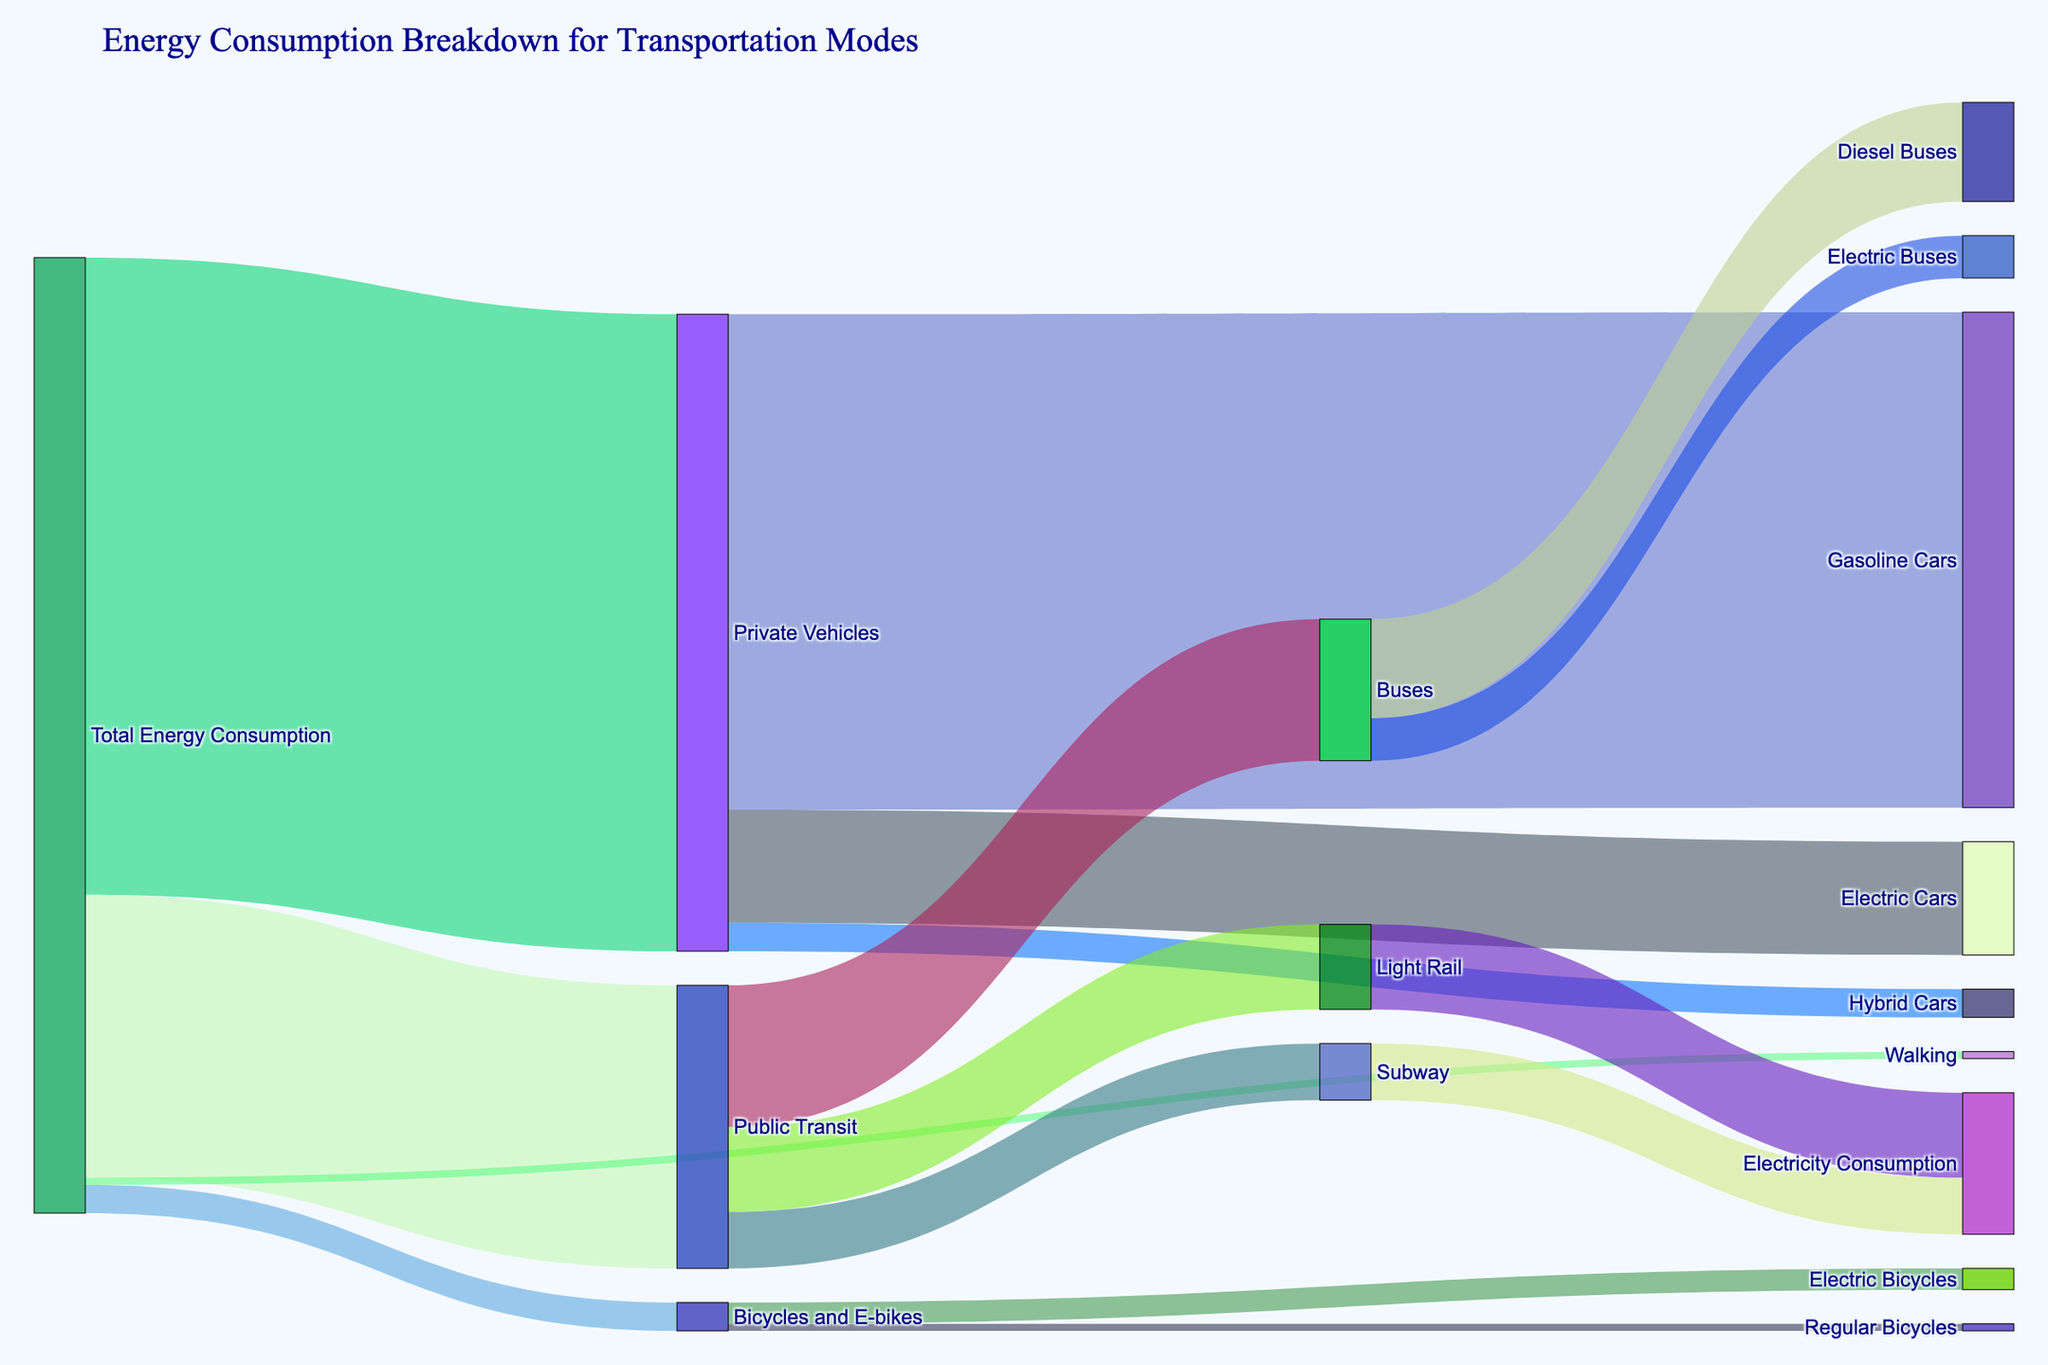How much total energy consumption is attributed to Private Vehicles? We look at the link connecting "Total Energy Consumption" to "Private Vehicles" and observe the value.
Answer: 450 Which mode of public transit has the highest energy consumption? We find the three branches under "Public Transit" (Buses, Light Rail, and Subway) and compare their values, which are 100, 60, and 40 respectively. "Buses" has the highest energy consumption.
Answer: Buses How is the energy consumption divided among Gasoline Cars, Electric Cars, and Hybrid Cars within Private Vehicles? We look at the links emerging from "Private Vehicles" to "Gasoline Cars" (350), "Electric Cars" (80), and "Hybrid Cars" (20). Summing these up confirms the total matches 450, indicating the breakdown.
Answer: 350 for Gasoline Cars, 80 for Electric Cars, 20 for Hybrid Cars What is the combined energy consumption of Electric Bicycles and Regular Bicycles? We look at the links from "Bicycles and E-bikes" to "Electric Bicycles" (15) and "Regular Bicycles" (5). Adding these values gives the total energy consumption for Bicycles and E-bikes.
Answer: 20 What percentage of total energy consumption is used by Public Transit? From the diagram, "Public Transit" uses 200 units. We compare this to the total energy consumption (675 units). The percentage is (200/675) * 100.
Answer: 29.63% Which type of vehicle within Private Vehicles consumes the least energy? Looking at the branches under "Private Vehicles," we compare the values for "Gasoline Cars" (350), "Electric Cars" (80), and "Hybrid Cars" (20). "Hybrid Cars" consumes the least energy.
Answer: Hybrid Cars Between Electric Buses and Diesel Buses, which consumes more energy? Under "Buses," we compare "Diesel Buses" (70) and "Electric Buses" (30). "Diesel Buses" has the higher consumption value.
Answer: Diesel Buses What is the energy consumption per person for each transportation mode, given public transit serves 100,000 people and private vehicles serve 50,000 people? First, calculate per person for Public Transit: 200,000/100,000 = 2 units per person. For Private Vehicles: 450,000/50,000 = 9 units per person.
Answer: 2 units/person for Public Transit, 9 units/person for Private Vehicles 